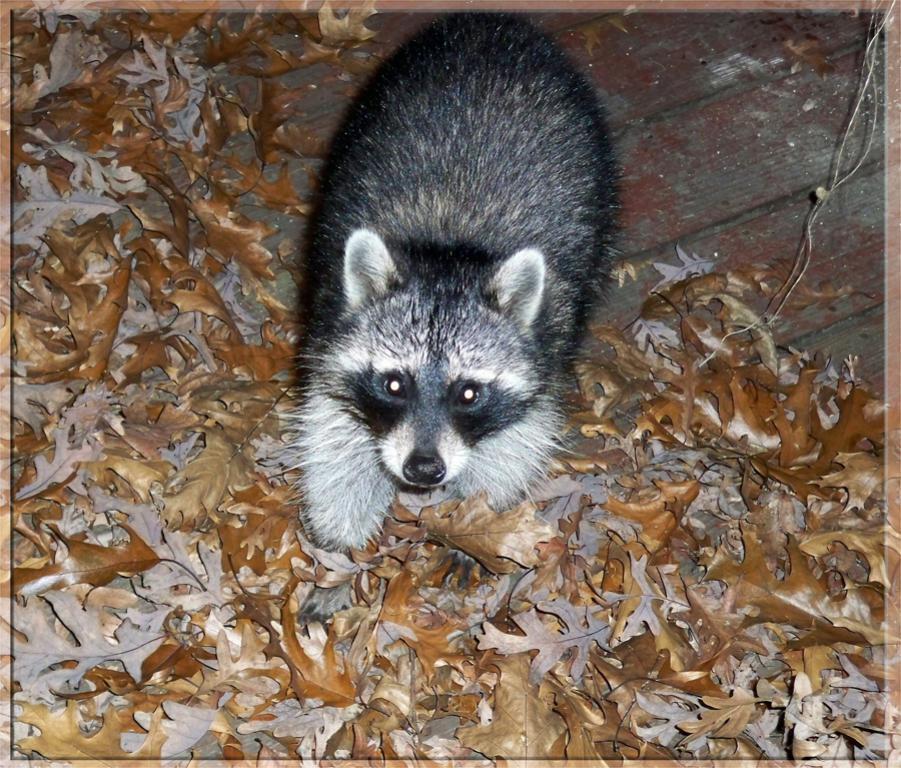Describe this image in one or two sentences. In this picture we can see the animal sitting on the dry leaves. 